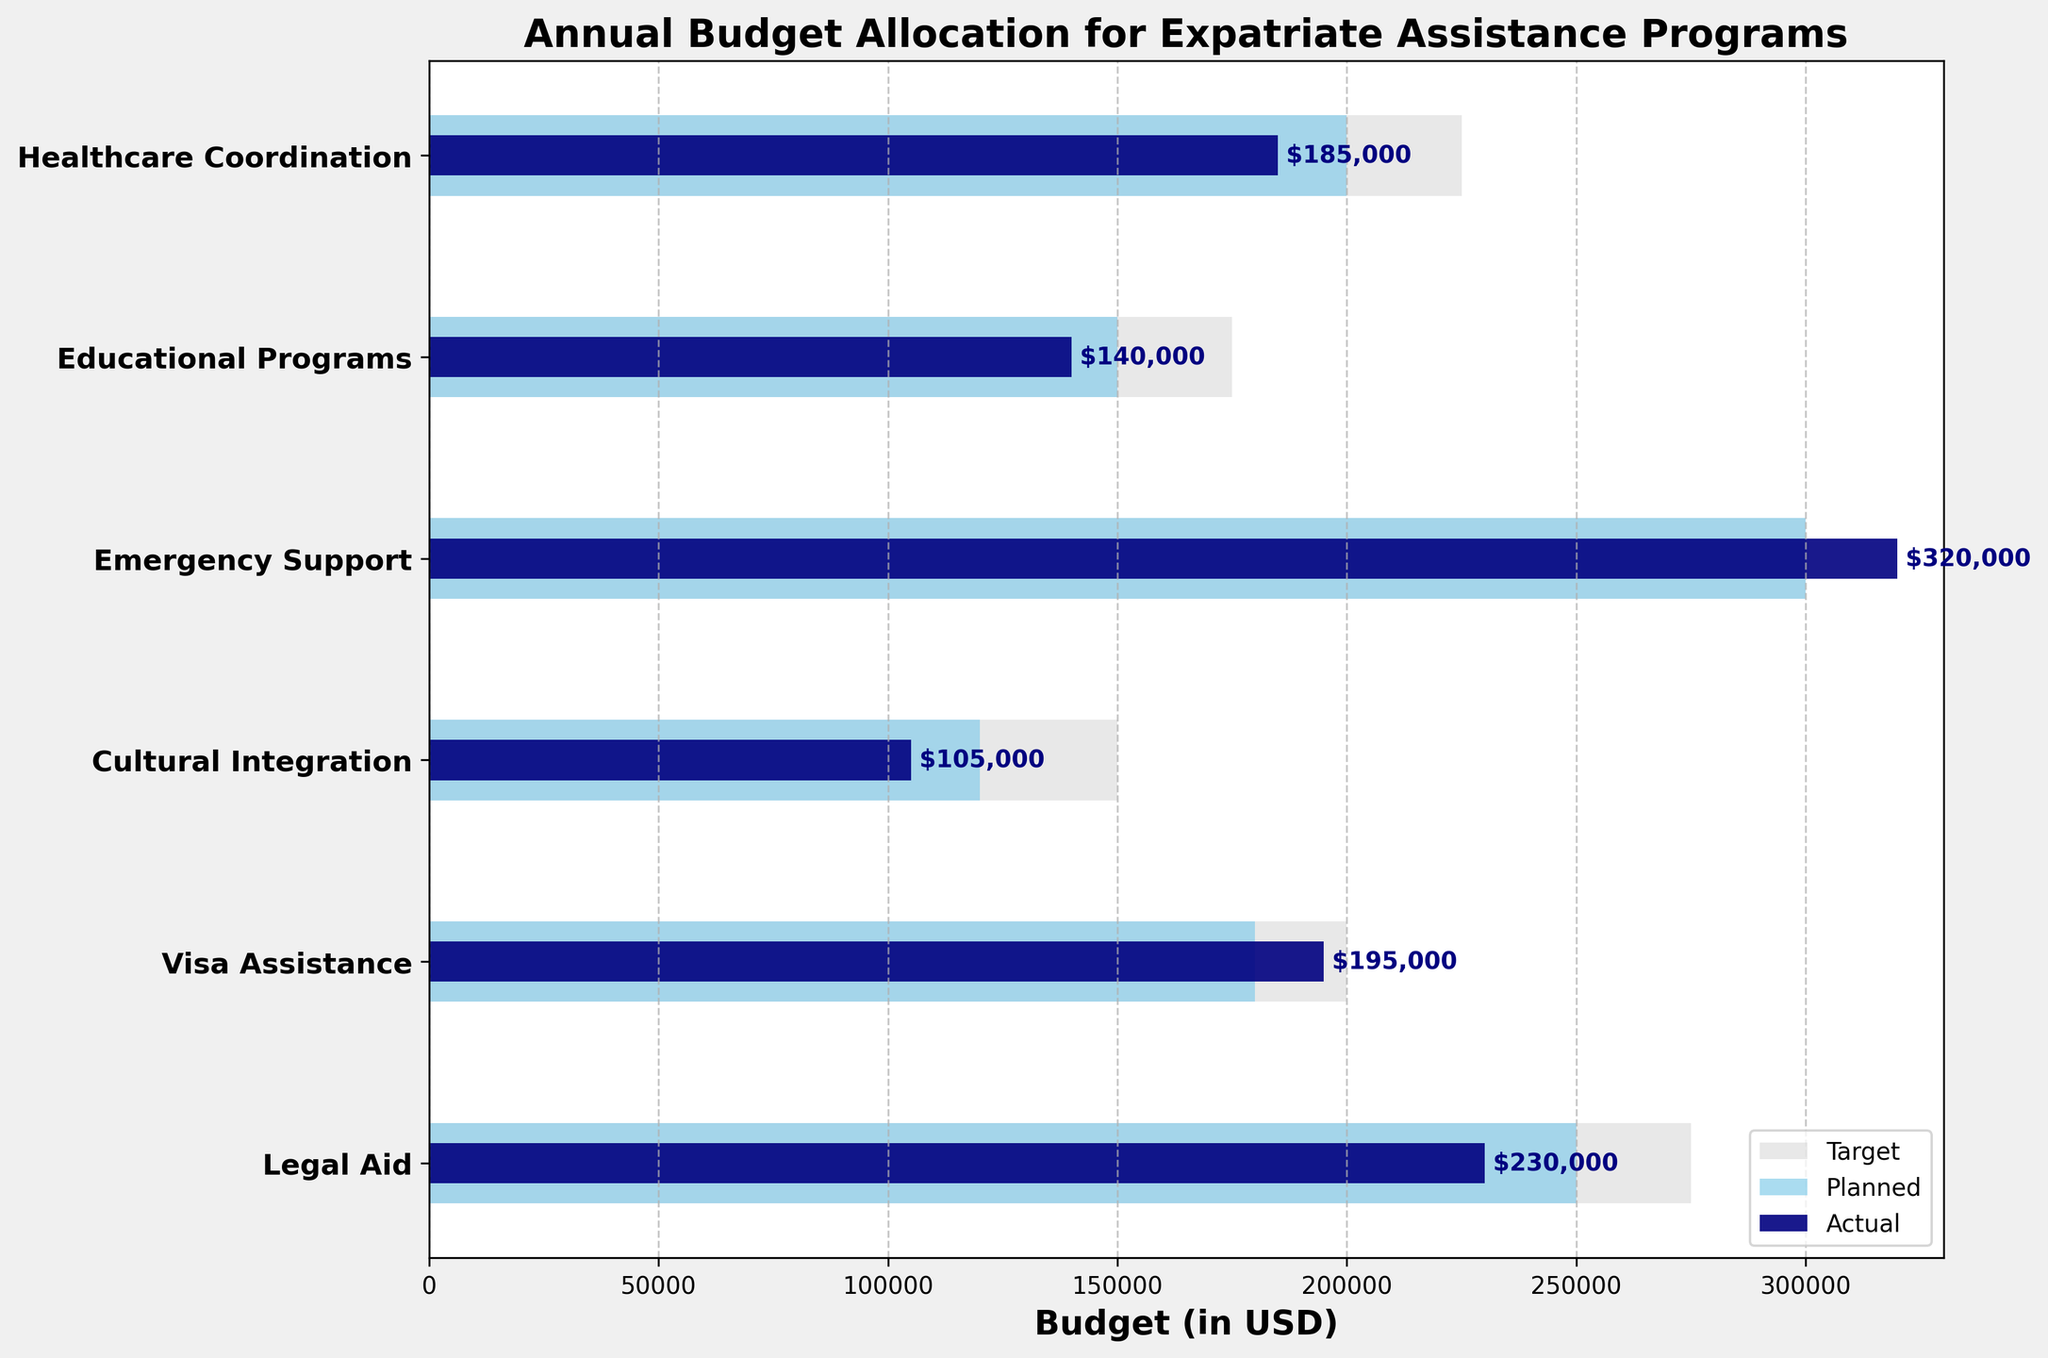What's the title of the figure? The title is displayed at the top of the figure. It reads 'Annual Budget Allocation for Expatriate Assistance Programs'.
Answer: 'Annual Budget Allocation for Expatriate Assistance Programs' How many categories are shown in the plot? Count the number of labels on the y-axis. There are 6 labels, each representing a different category.
Answer: 6 Which category has the highest actual expenditure? Look at the bars representing the actual expenditure and find the longest one. The 'Emergency Support' category has the highest actual expenditure.
Answer: 'Emergency Support' How much was the actual expenditure for Legal Aid? Find the bar corresponding to 'Legal Aid' and check the value label at the end of the navy bar (actual expenditure). It is $230,000.
Answer: $230,000 Which categories did not meet their planned budget? Compare the length of the actual expenditure bars (navy) to the planned expenditure bars (sky blue). 'Legal Aid', 'Cultural Integration', 'Educational Programs', and 'Healthcare Coordination' did not meet their planned budget.
Answer: 'Legal Aid', 'Cultural Integration', 'Educational Programs', 'Healthcare Coordination' What is the difference between the planned and actual expenditures for Visa Assistance? Subtract the actual expenditure ($195,000) from the planned expenditure ($180,000) for 'Visa Assistance'. The difference is $15,000.
Answer: $15,000 What is the average of the actual expenditures across all categories? Sum the actual expenditures and divide by the number of categories: ($230,000 + $195,000 + $105,000 + $320,000 + $140,000 + $185,000) / 6. The answer is approximately $195,833.33.
Answer: $195,833.33 Which category exceeded its target expenditure? Compare the actual expenditure bars to the target expenditure bars (light grey). Only 'Emergency Support' exceeded its target expenditure.
Answer: 'Emergency Support' How much more did 'Emergency Support' actually spend compared to its target? Subtract the target expenditure ($300,000) from the actual expenditure ($320,000) for 'Emergency Support'. The difference is $20,000.
Answer: $20,000 What was the planned expenditure for Healthcare Coordination? Look at the bar corresponding to 'Healthcare Coordination' and note the value indicated by the sky blue bar (planned expenditure). It is $200,000.
Answer: $200,000 